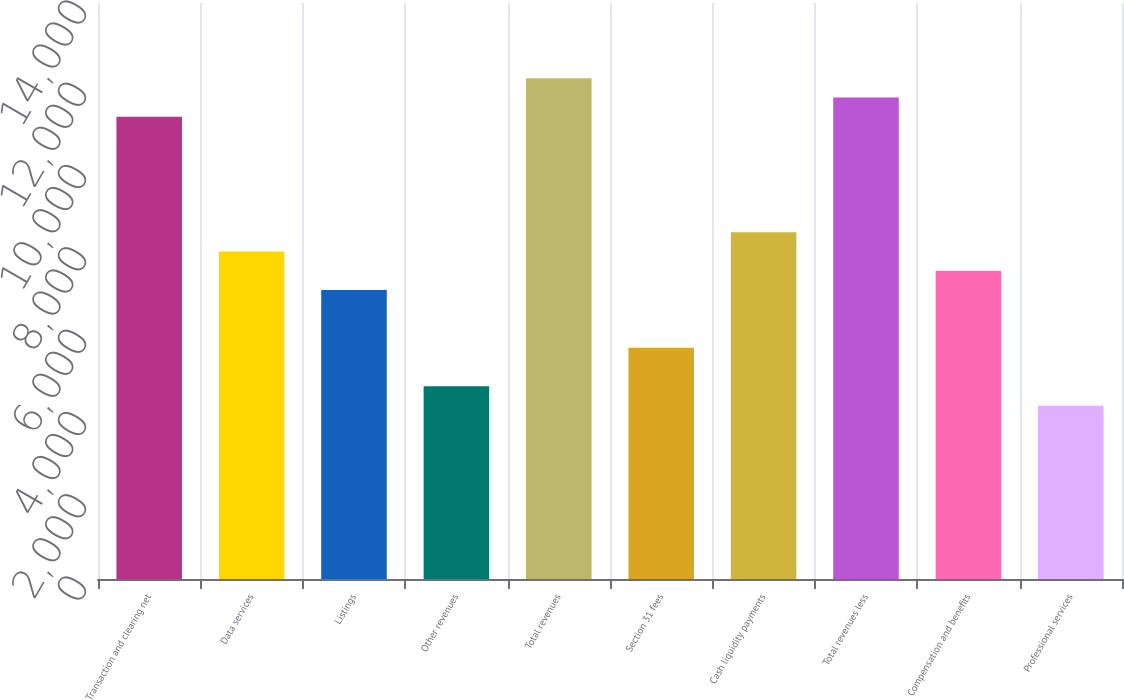Convert chart. <chart><loc_0><loc_0><loc_500><loc_500><bar_chart><fcel>Transaction and clearing net<fcel>Data services<fcel>Listings<fcel>Other revenues<fcel>Total revenues<fcel>Section 31 fees<fcel>Cash liquidity payments<fcel>Total revenues less<fcel>Compensation and benefits<fcel>Professional services<nl><fcel>11235.9<fcel>7958.96<fcel>7022.68<fcel>4681.98<fcel>12172.2<fcel>5618.26<fcel>8427.1<fcel>11704.1<fcel>7490.82<fcel>4213.84<nl></chart> 